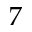Convert formula to latex. <formula><loc_0><loc_0><loc_500><loc_500>7</formula> 